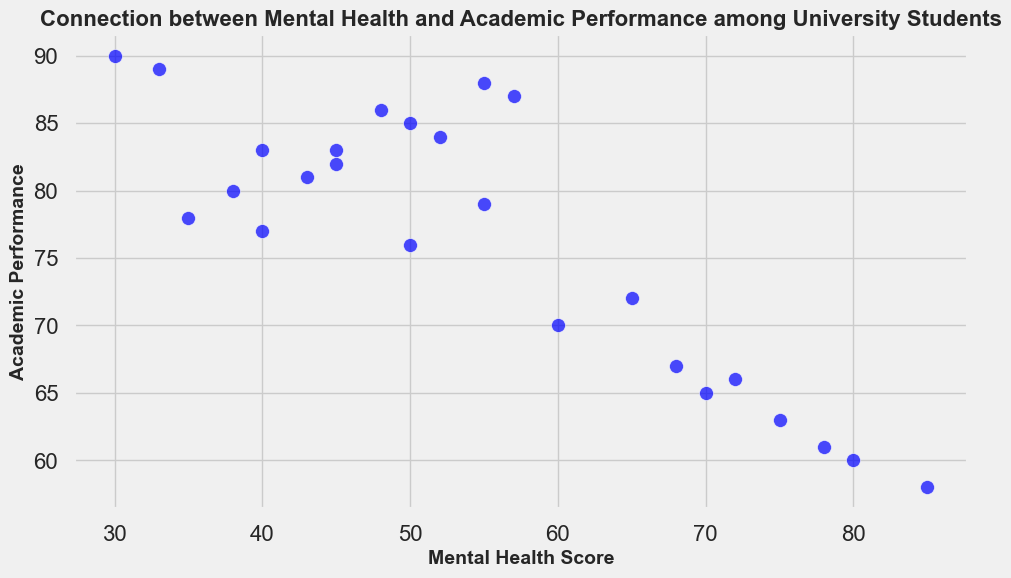How does academic performance tend to vary with increasing mental health scores? To answer this, we observe the general trend in the scatter plot. As mental health scores increase, the points slope downward, indicating a general decrease in academic performance.
Answer: Academic performance generally decreases with higher mental health scores Which student has the highest mental health score, and what is their academic performance? By identifying the point with the highest mental health score on the x-axis, we see that Student 22 has the highest score (85) with an academic performance of 58.
Answer: Student 22, with an academic performance of 58 Who has the highest academic performance and what is their mental health score? The point farthest up on the y-axis represents the highest academic performance. Student 8 has the highest academic performance (90) and a mental health score of 30.
Answer: Student 8, with a mental health score of 30 Which pair of students have the largest difference in mental health scores? To determine this, we look for the maximum horizontal distance between two points. Students 8 and 22 have mental health scores of 30 and 85, respectively, with a difference of 55.
Answer: Students 8 and 22 What is the average mental health score of students with academic performance above 80? First, identify students with academic performance above 80 (Students 1, 2, 3, 5, 7, 8, 10, 11, 12, 13, 14, 15, 17, 19, 20, 21, 24, 25). Sum their mental health scores (35, 50, 45, 55, 80, 30, 75, 40, 38, 68, 52, 43, 57, 40, 55, 48, 50, 45) which equals 906. There are 18 such students, so the average is 906 / 18 = 50.33.
Answer: 50.33 Do most students with a mental health score above 60 have an academic performance below 70? To check this, count the points with mental health scores above 60 and see if their academic performance is below 70. Students above 60 are 4, 6, 7, 9, 10, 13, 16, 18, 22. Of these, seven (4, 6, 7, 10, 13, 16, 18, 22) have academic performance below 70, more than half.
Answer: Yes, most do Is there a student with the same mental health and academic performance score? Looking at the plot, there is no point where the x-value (mental health score) and the y-value (academic performance) are the same.
Answer: No What is the median academic performance among students with a mental health score below 50? Identify scores of students with mental health below 50 (Students 1, 8, 11, 12, 19, 23). Their academic performances (78, 90, 83, 80, 77, 89) sorted are 77, 78, 80, 83, 89, 90. The median is the middle value, so (80+83)/2 = 81.5.
Answer: 81.5 